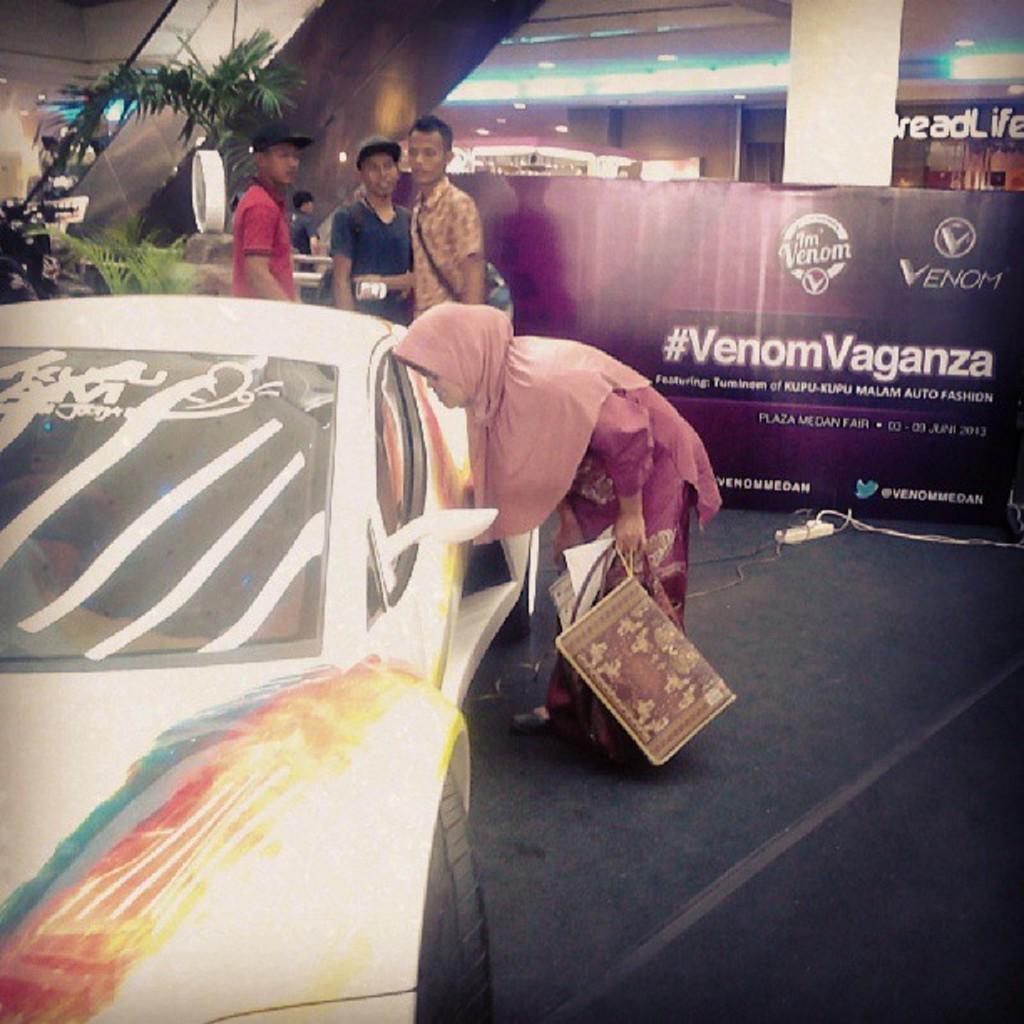Could you give a brief overview of what you see in this image? In this image, we can see a vehicle on the path. Beside the vehicle there is a woman holding some objects. In the background, there are banners, people, house plants, wires, lights, pillar, escalator and few objects. 